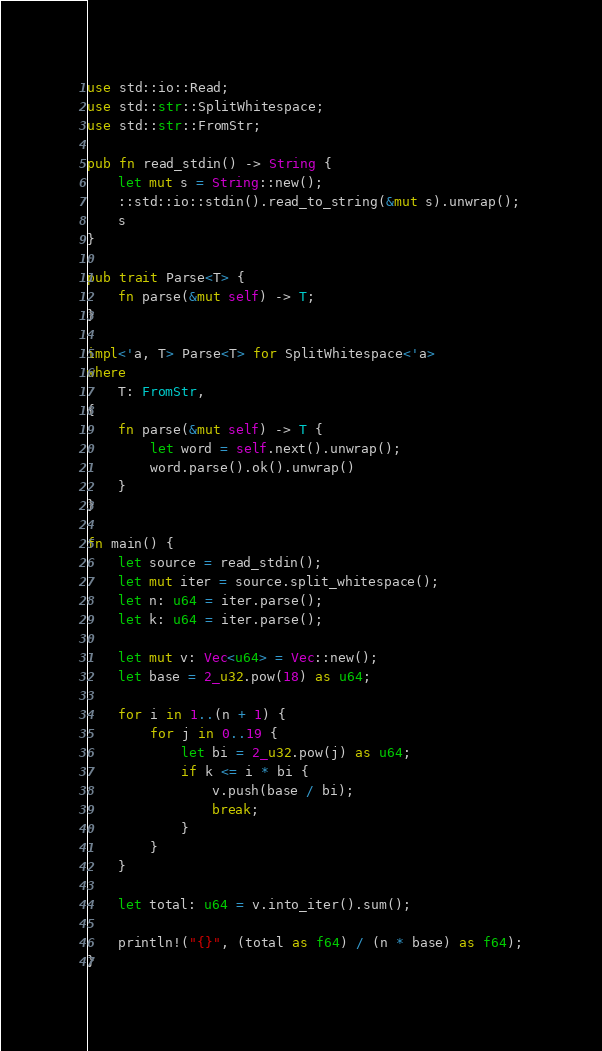Convert code to text. <code><loc_0><loc_0><loc_500><loc_500><_Rust_>use std::io::Read;
use std::str::SplitWhitespace;
use std::str::FromStr;

pub fn read_stdin() -> String {
    let mut s = String::new();
    ::std::io::stdin().read_to_string(&mut s).unwrap();
    s
}

pub trait Parse<T> {
    fn parse(&mut self) -> T;
}

impl<'a, T> Parse<T> for SplitWhitespace<'a>
where
    T: FromStr,
{
    fn parse(&mut self) -> T {
        let word = self.next().unwrap();
        word.parse().ok().unwrap()
    }
}

fn main() {
    let source = read_stdin();
    let mut iter = source.split_whitespace();
    let n: u64 = iter.parse();
    let k: u64 = iter.parse();

    let mut v: Vec<u64> = Vec::new();
    let base = 2_u32.pow(18) as u64;

    for i in 1..(n + 1) {
        for j in 0..19 {
            let bi = 2_u32.pow(j) as u64;
            if k <= i * bi {
                v.push(base / bi);
                break;
            }
        }
    }

    let total: u64 = v.into_iter().sum();

    println!("{}", (total as f64) / (n * base) as f64);
}</code> 